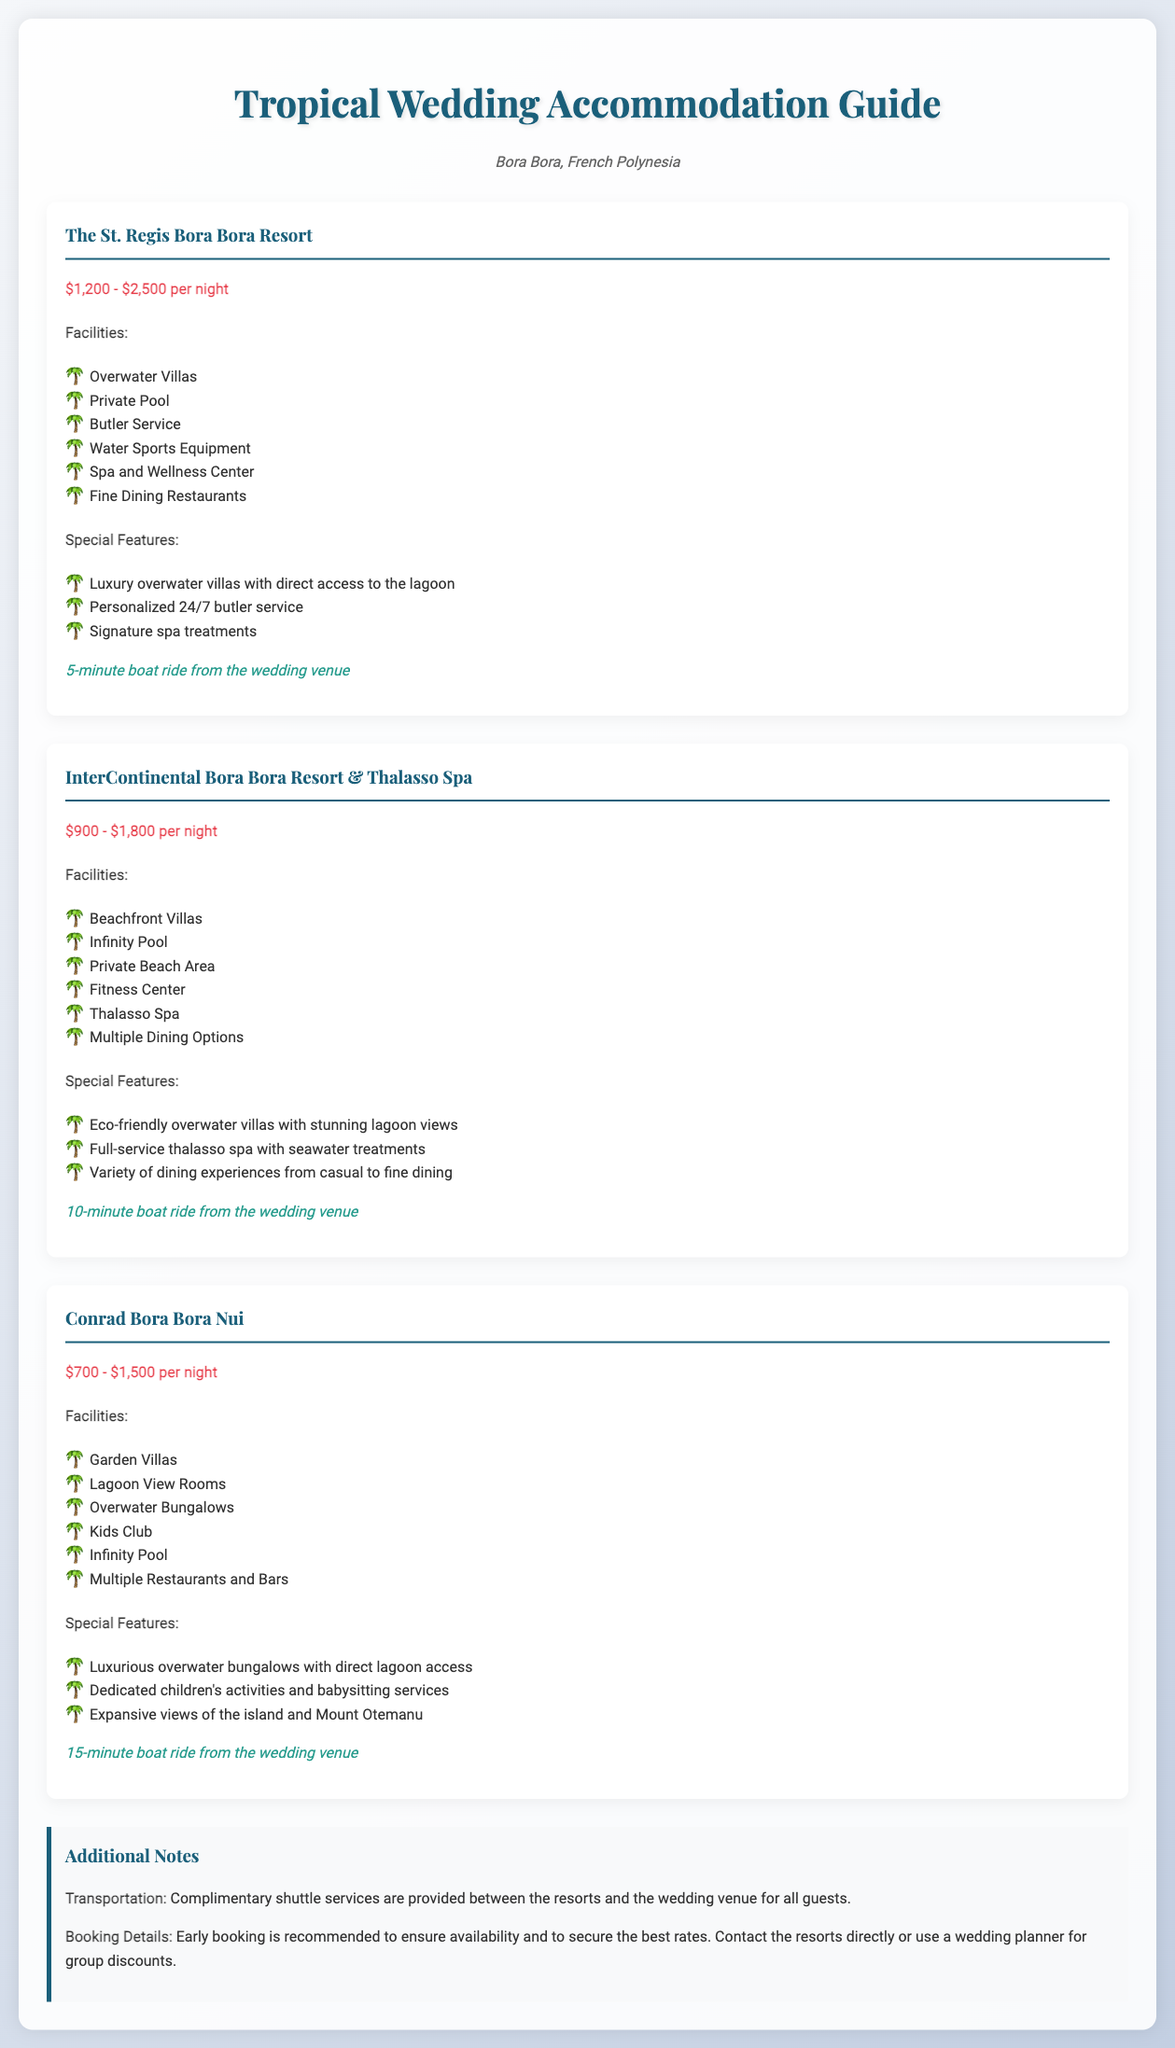What is the price range for The St. Regis Bora Bora Resort? The price range is mentioned in the document as $1,200 - $2,500 per night.
Answer: $1,200 - $2,500 per night How far is the InterContinental Bora Bora Resort from the wedding venue? The document specifies that it is a 10-minute boat ride from the wedding venue.
Answer: 10-minute boat ride What special feature does Conrad Bora Bora Nui offer for children? The document states that it has dedicated children's activities and babysitting services.
Answer: Kids Club Which resort offers a private beach area? The InterContinental Bora Bora Resort & Thalasso Spa is noted for having a private beach area.
Answer: InterContinental Bora Bora Resort & Thalasso Spa What type of accommodation options does The St. Regis Bora Bora Resort include? It includes Overwater Villas as listed in the facilities section.
Answer: Overwater Villas What is one reason early booking is recommended? The document suggests that early booking is recommended to ensure availability and to secure the best rates.
Answer: To ensure availability How many dining options does the InterContinental Bora Bora Resort & Thalasso Spa provide? It mentions that there are multiple dining options available.
Answer: Multiple Dining Options What is the maximum nightly rate for the Conrad Bora Bora Nui? The document lists the maximum nightly rate as $1,500.
Answer: $1,500 